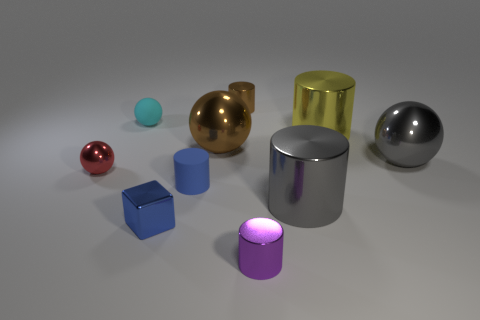Subtract all gray cylinders. How many cylinders are left? 4 Subtract all blue cylinders. How many cylinders are left? 4 Subtract all gray cylinders. Subtract all brown cubes. How many cylinders are left? 4 Subtract all spheres. How many objects are left? 6 Add 10 large green things. How many large green things exist? 10 Subtract 1 gray spheres. How many objects are left? 9 Subtract all large purple matte cubes. Subtract all brown metallic objects. How many objects are left? 8 Add 1 purple cylinders. How many purple cylinders are left? 2 